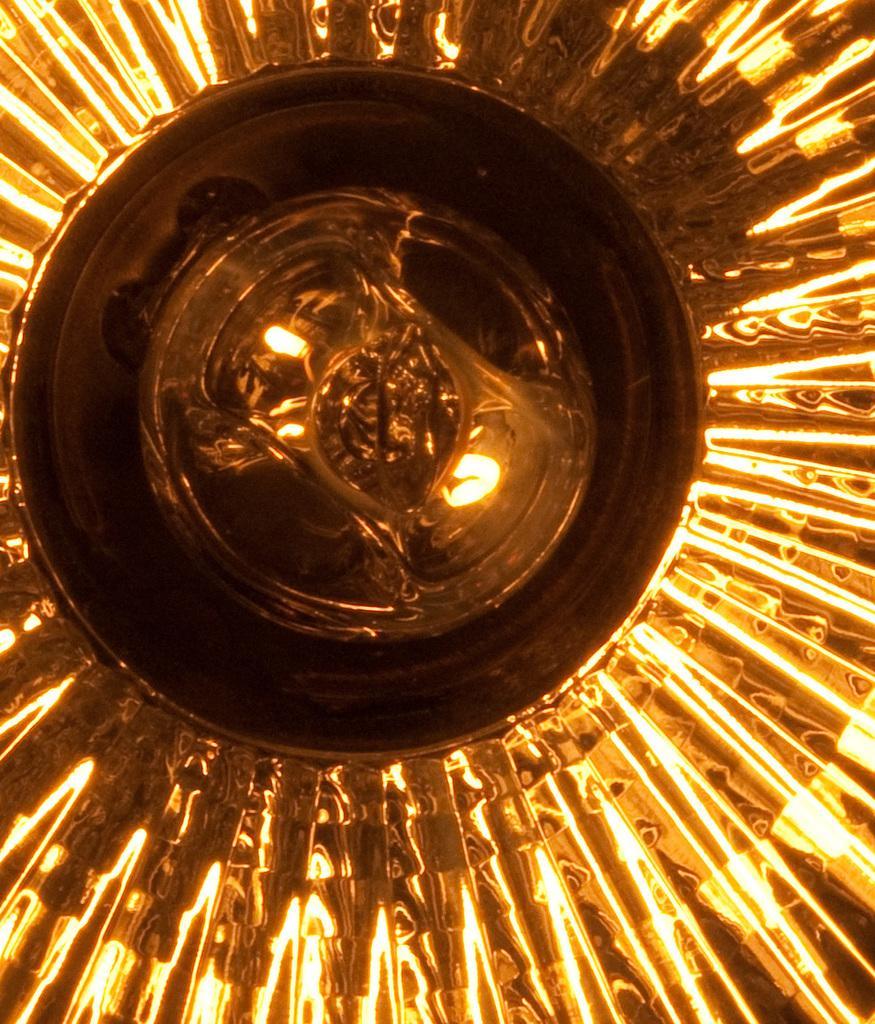Please provide a concise description of this image. In this picture we can see lights. 